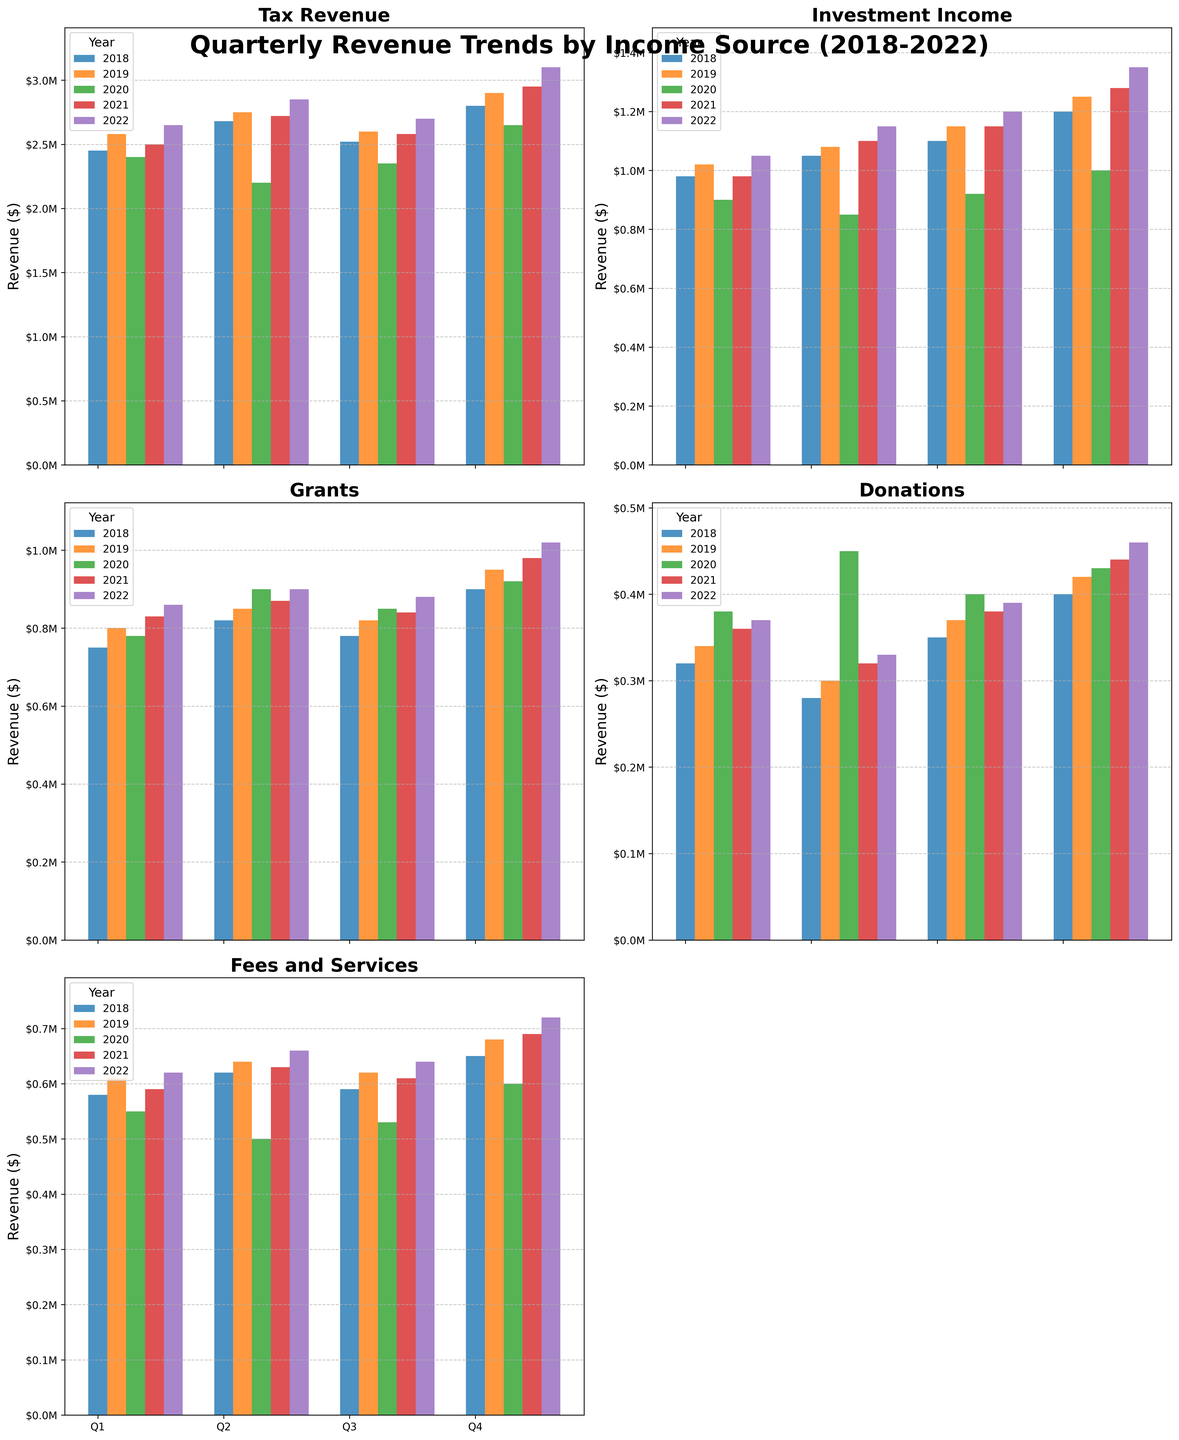What is the title of the figure? The title of the figure is located at the top and provides an overview of what the figure represents. It reads 'Quarterly Revenue Trends by Income Source (2018-2022)'.
Answer: Quarterly Revenue Trends by Income Source (2018-2022) How many income sources are shown in the figure? The figure contains multiple subplots, each representing a different income source, and there are five subplots in total.
Answer: Five Which income source had the highest revenue in Q4 of 2022? Review each subplot's Q4 2022 bar. The 'Tax Revenue' subplot shows the highest bar in Q4 2022 compared to other sources.
Answer: Tax Revenue What was the revenue from 'Donations' in Q2 of 2021? Locate the 'Donations' subplot, then find the bar corresponding to Q2 2021. The revenue is 320,000 dollars.
Answer: $320,000 Which income source shows a general increasing trend over the years? Examine the subplots' bars from 2018 to 2022. 'Tax Revenue' and 'Investment Income' subplots show a consistent upward trend.
Answer: Tax Revenue and Investment Income Compare the 'Fees and Services' revenue between Q3 of 2019 and Q3 of 2021. Which is higher? Check the 'Fees and Services' subplot. The Q3 2019 bar is slightly higher than the Q3 2021 bar.
Answer: Q3 of 2019 What difference do you find between the 'Tax Revenue' in Q4 of 2018 and Q4 of 2019? Check the 'Tax Revenue' bars for Q4 2018 and Q4 2019. Q4 2019 has a revenue of 2,900,000 dollars, and Q4 2018 has 2,800,000 dollars. The difference is 100,000 dollars.
Answer: $100,000 What is the average 'Investment Income' for the year 2020? Add the 'Investment Income' for all quarters of 2020 (900000, 850000, 920000, 1000000) and divide by 4. The sum of 3670000 divided by 4 is 917500 dollars.
Answer: $917,500 Which year had the lowest 'Grants' income in Q2? Check the 'Grants' subplot, focusing on Q2 bars for each year. The lowest bar in Q2 is for 2020 with a revenue of 900,000 dollars.
Answer: 2020 Identify the year and quarter with the highest overall revenue from 'Fees and Services.' Examine the 'Fees and Services' subplot, identifying the tallest bar. The tallest is Q4 of 2022, with a revenue of 720,000 dollars.
Answer: Q4 of 2022 